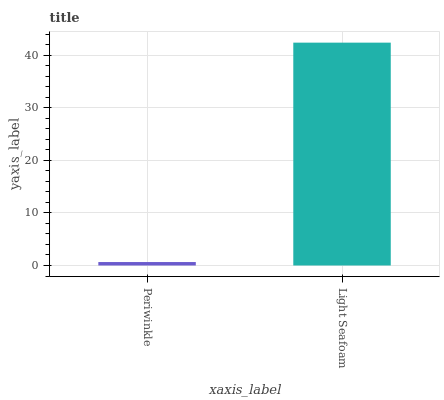Is Periwinkle the minimum?
Answer yes or no. Yes. Is Light Seafoam the maximum?
Answer yes or no. Yes. Is Light Seafoam the minimum?
Answer yes or no. No. Is Light Seafoam greater than Periwinkle?
Answer yes or no. Yes. Is Periwinkle less than Light Seafoam?
Answer yes or no. Yes. Is Periwinkle greater than Light Seafoam?
Answer yes or no. No. Is Light Seafoam less than Periwinkle?
Answer yes or no. No. Is Light Seafoam the high median?
Answer yes or no. Yes. Is Periwinkle the low median?
Answer yes or no. Yes. Is Periwinkle the high median?
Answer yes or no. No. Is Light Seafoam the low median?
Answer yes or no. No. 